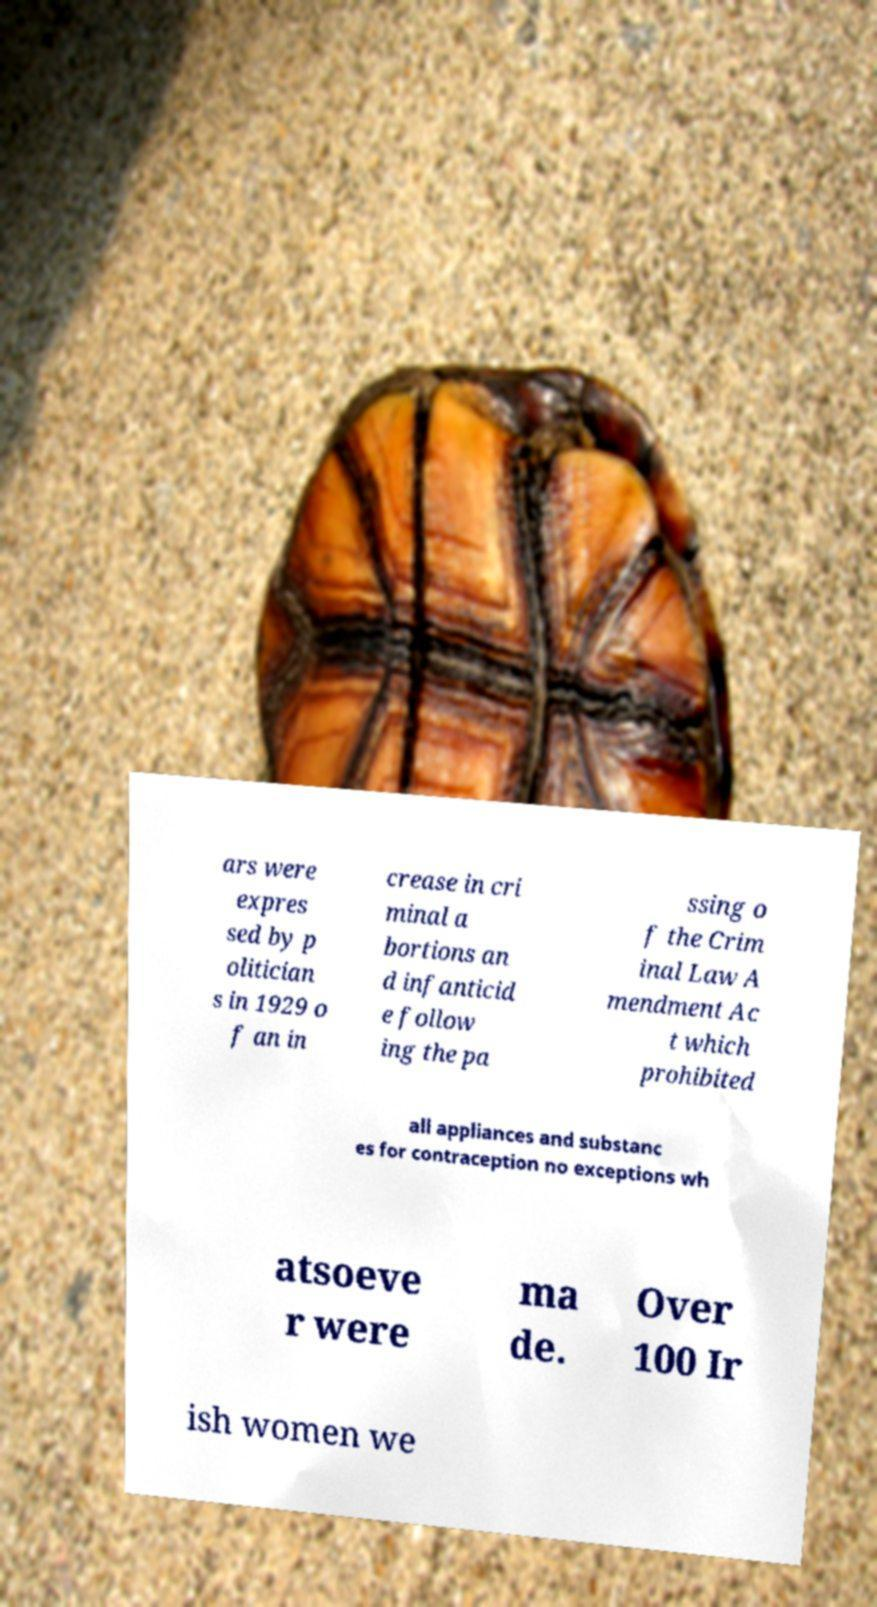I need the written content from this picture converted into text. Can you do that? ars were expres sed by p olitician s in 1929 o f an in crease in cri minal a bortions an d infanticid e follow ing the pa ssing o f the Crim inal Law A mendment Ac t which prohibited all appliances and substanc es for contraception no exceptions wh atsoeve r were ma de. Over 100 Ir ish women we 